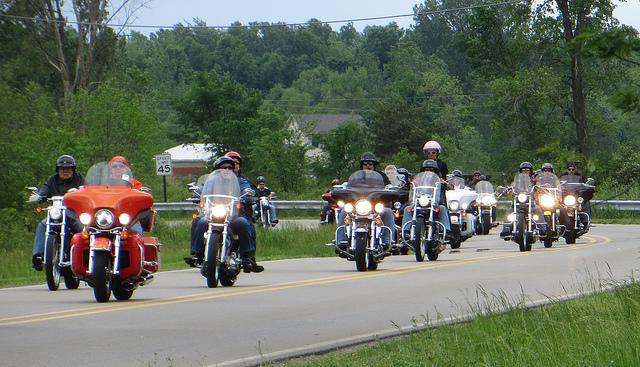What are the people doing with their motorcycles? riding 